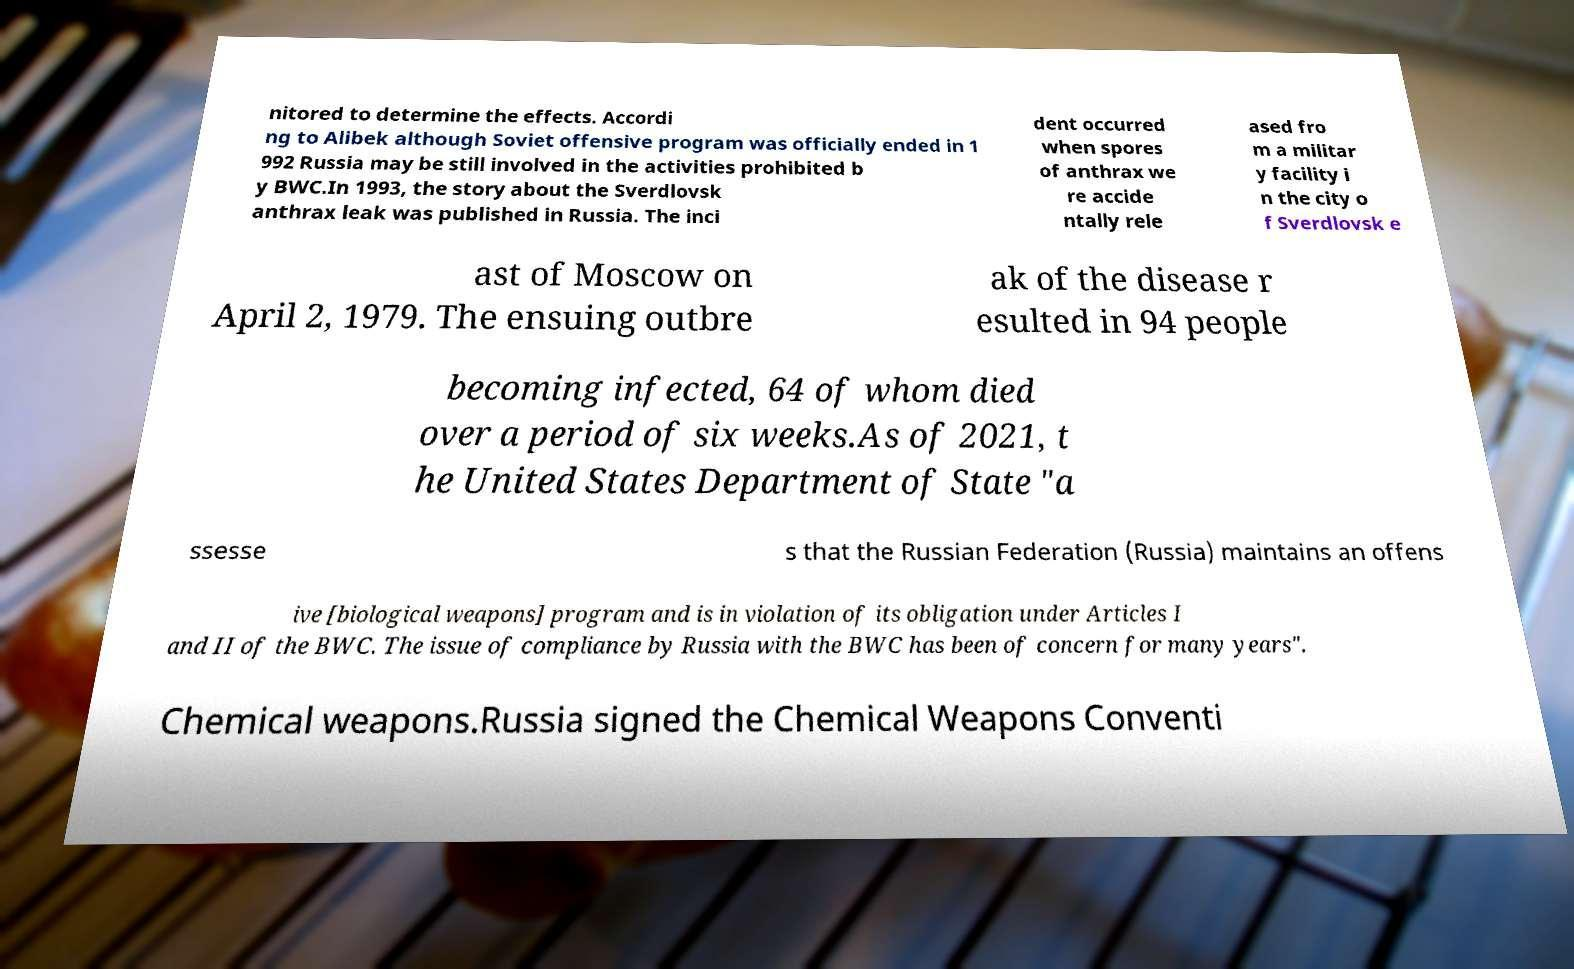What messages or text are displayed in this image? I need them in a readable, typed format. nitored to determine the effects. Accordi ng to Alibek although Soviet offensive program was officially ended in 1 992 Russia may be still involved in the activities prohibited b y BWC.In 1993, the story about the Sverdlovsk anthrax leak was published in Russia. The inci dent occurred when spores of anthrax we re accide ntally rele ased fro m a militar y facility i n the city o f Sverdlovsk e ast of Moscow on April 2, 1979. The ensuing outbre ak of the disease r esulted in 94 people becoming infected, 64 of whom died over a period of six weeks.As of 2021, t he United States Department of State "a ssesse s that the Russian Federation (Russia) maintains an offens ive [biological weapons] program and is in violation of its obligation under Articles I and II of the BWC. The issue of compliance by Russia with the BWC has been of concern for many years". Chemical weapons.Russia signed the Chemical Weapons Conventi 